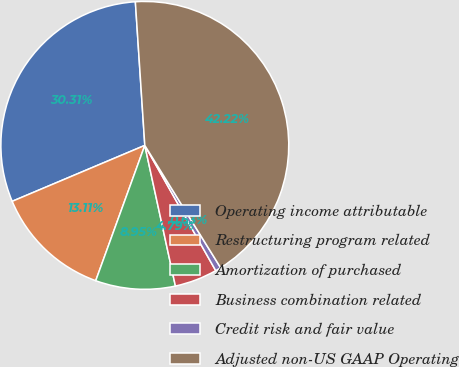Convert chart to OTSL. <chart><loc_0><loc_0><loc_500><loc_500><pie_chart><fcel>Operating income attributable<fcel>Restructuring program related<fcel>Amortization of purchased<fcel>Business combination related<fcel>Credit risk and fair value<fcel>Adjusted non-US GAAP Operating<nl><fcel>30.31%<fcel>13.11%<fcel>8.95%<fcel>4.79%<fcel>0.63%<fcel>42.22%<nl></chart> 